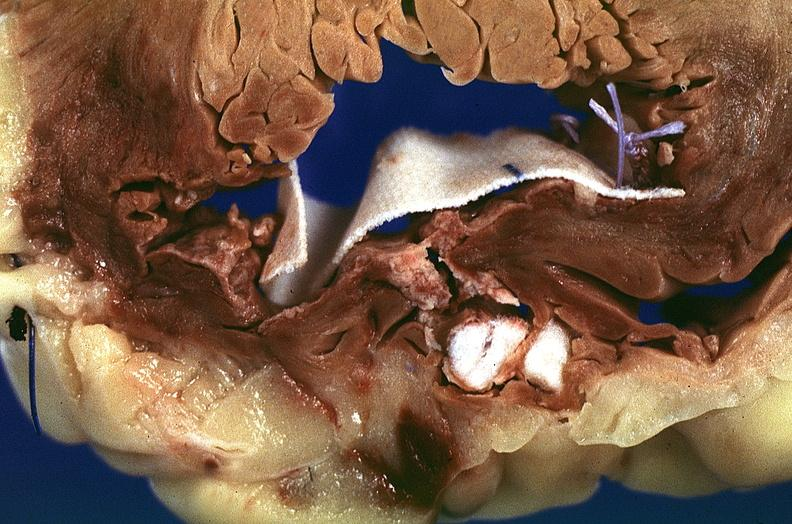does this image show heart, myocardial infarction, surgery to repair interventricular septum rupture?
Answer the question using a single word or phrase. Yes 